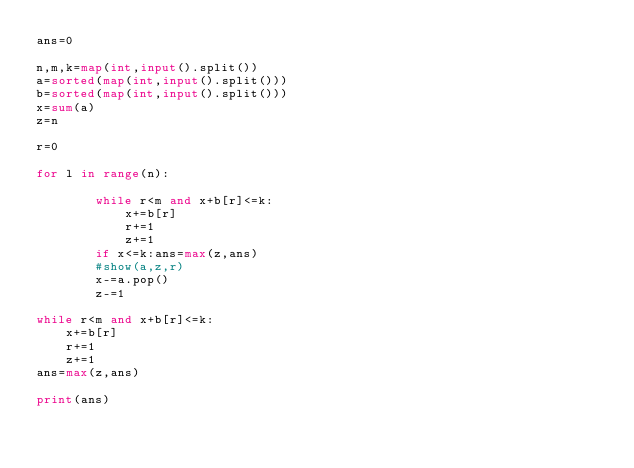Convert code to text. <code><loc_0><loc_0><loc_500><loc_500><_Python_>ans=0

n,m,k=map(int,input().split())
a=sorted(map(int,input().split()))
b=sorted(map(int,input().split()))
x=sum(a)
z=n

r=0

for l in range(n):
    
        while r<m and x+b[r]<=k:
            x+=b[r]
            r+=1
            z+=1
        if x<=k:ans=max(z,ans)
        #show(a,z,r)
        x-=a.pop()
        z-=1

while r<m and x+b[r]<=k:
    x+=b[r]
    r+=1
    z+=1
ans=max(z,ans)

print(ans)

</code> 